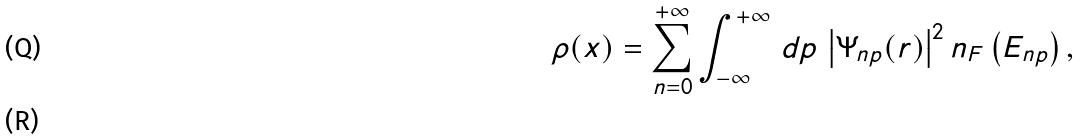Convert formula to latex. <formula><loc_0><loc_0><loc_500><loc_500>\rho ( x ) = \sum _ { n = 0 } ^ { + \infty } \int _ { - \infty } ^ { + \infty } \, d p \, \left | \Psi _ { n p } ( { r } ) \right | ^ { 2 } n _ { F } \left ( E _ { n p } \right ) , \\</formula> 